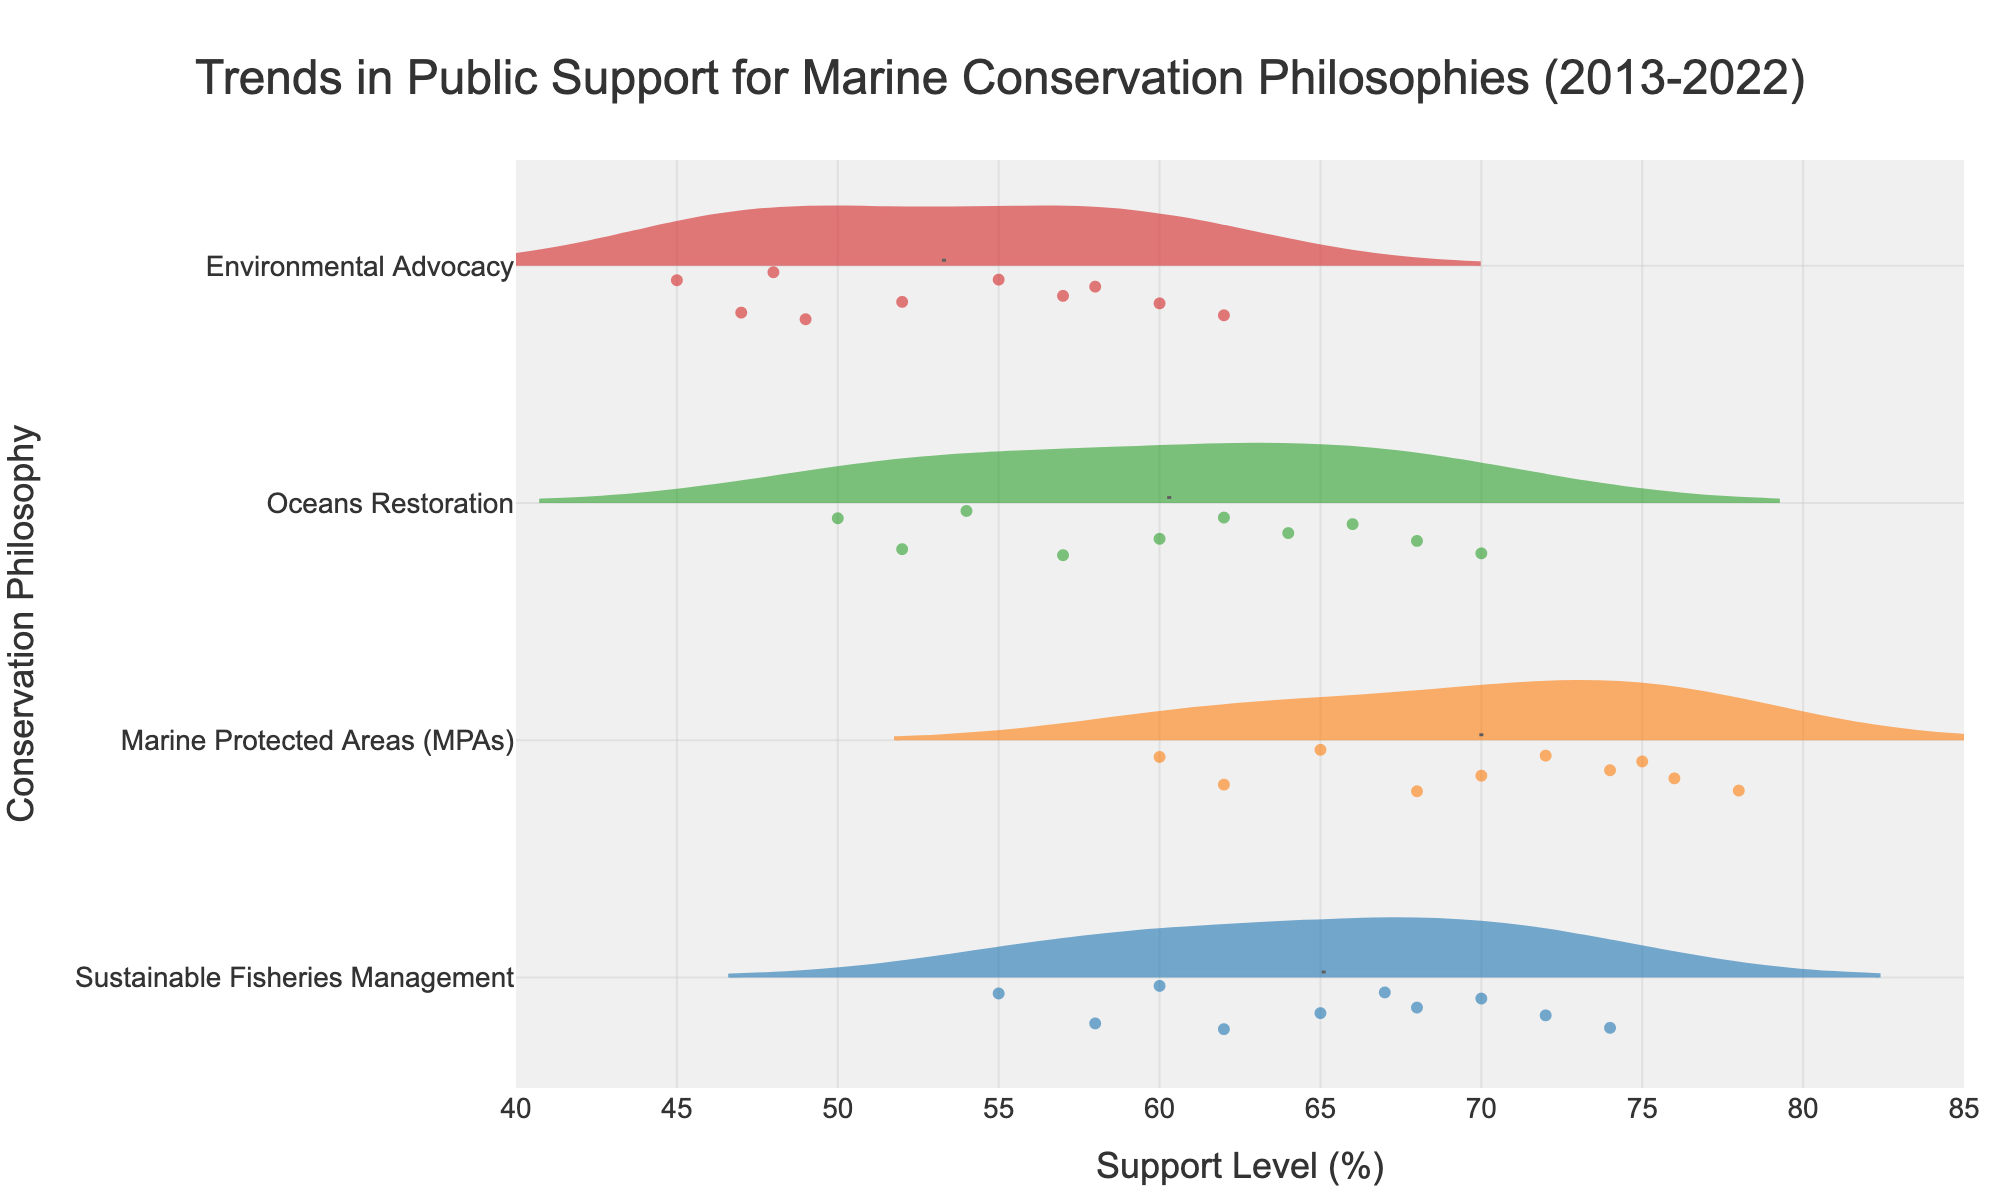What is the title of the figure? The title of the figure is usually displayed at the top of the chart. In this case, the title is "Trends in Public Support for Marine Conservation Philosophies (2013-2022)."
Answer: Trends in Public Support for Marine Conservation Philosophies (2013-2022) Which marine conservation philosophy has the highest public support in 2022 according to the plot? Look at the right side of the horizontal violin chart where each philosophy is listed. The highest point in 2022 belongs to Marine Protected Areas (MPAs).
Answer: Marine Protected Areas (MPAs) How does the support for Environmental Advocacy change over the decade? Observe the density distribution for Environmental Advocacy from 2013 to 2022. It starts at a lower range and incrementally increases, indicating a gradual rise in support.
Answer: Increases Compare the average support for Sustainable Fisheries Management and Marine Protected Areas (MPAs) over the decade. Which one has higher average support? By looking at the violin plots, which include median and mean lines, observe the position of these lines. The mean line for Marine Protected Areas (MPAs) is consistently higher than that of Sustainable Fisheries Management.
Answer: Marine Protected Areas (MPAs) What can you infer about public support trends for Oceans Restoration? The trend for Oceans Restoration can be identified through the violin plots. The density centers shift upwards over the years, indicating increased public support.
Answer: Increasing What is the range of support levels for Marine Protected Areas (MPAs) in 2017? Look at the violin plot corresponding to MPAs for 2017. The range is determined by the spread of the violin plot, which extends from approximately 65% to 70%.
Answer: 65%-70% Is there any philosophy that shows a steady increase in public support each year without any decline? By examining the progression of each violin plot, observe that Marine Protected Areas (MPAs) consistently shows an increase in public support each year.
Answer: Marine Protected Areas (MPAs) Based on the chart, which philosophy shows the highest variability in public support over the decade? Variability can be inferred from the width and spread of the violin plots. Sustainable Fisheries Management has a noticeable spread, indicating higher variability in public support.
Answer: Sustainable Fisheries Management How does the public support for Environmental Advocacy in 2019 compare to that in 2022? Compare the positions of data points for Environmental Advocacy in the years 2019 and 2022. There is an evident increase in support from 57% in 2019 to 62% in 2022.
Answer: Increase What is the lowest level of public support recorded for Sustainable Fisheries Management over the decade? Observe the leftmost edge of the Sustainable Fisheries Management violin plots. The lowest data point is in 2013, around 55%.
Answer: 55% 